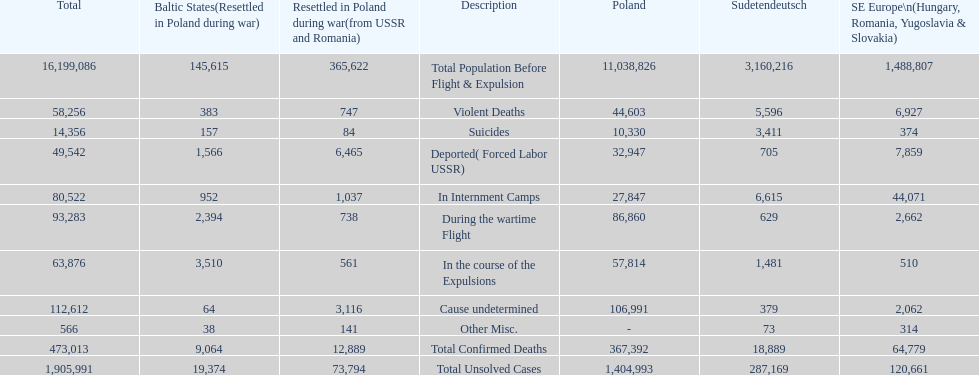What is the total of deaths in internment camps and during the wartime flight? 173,805. 